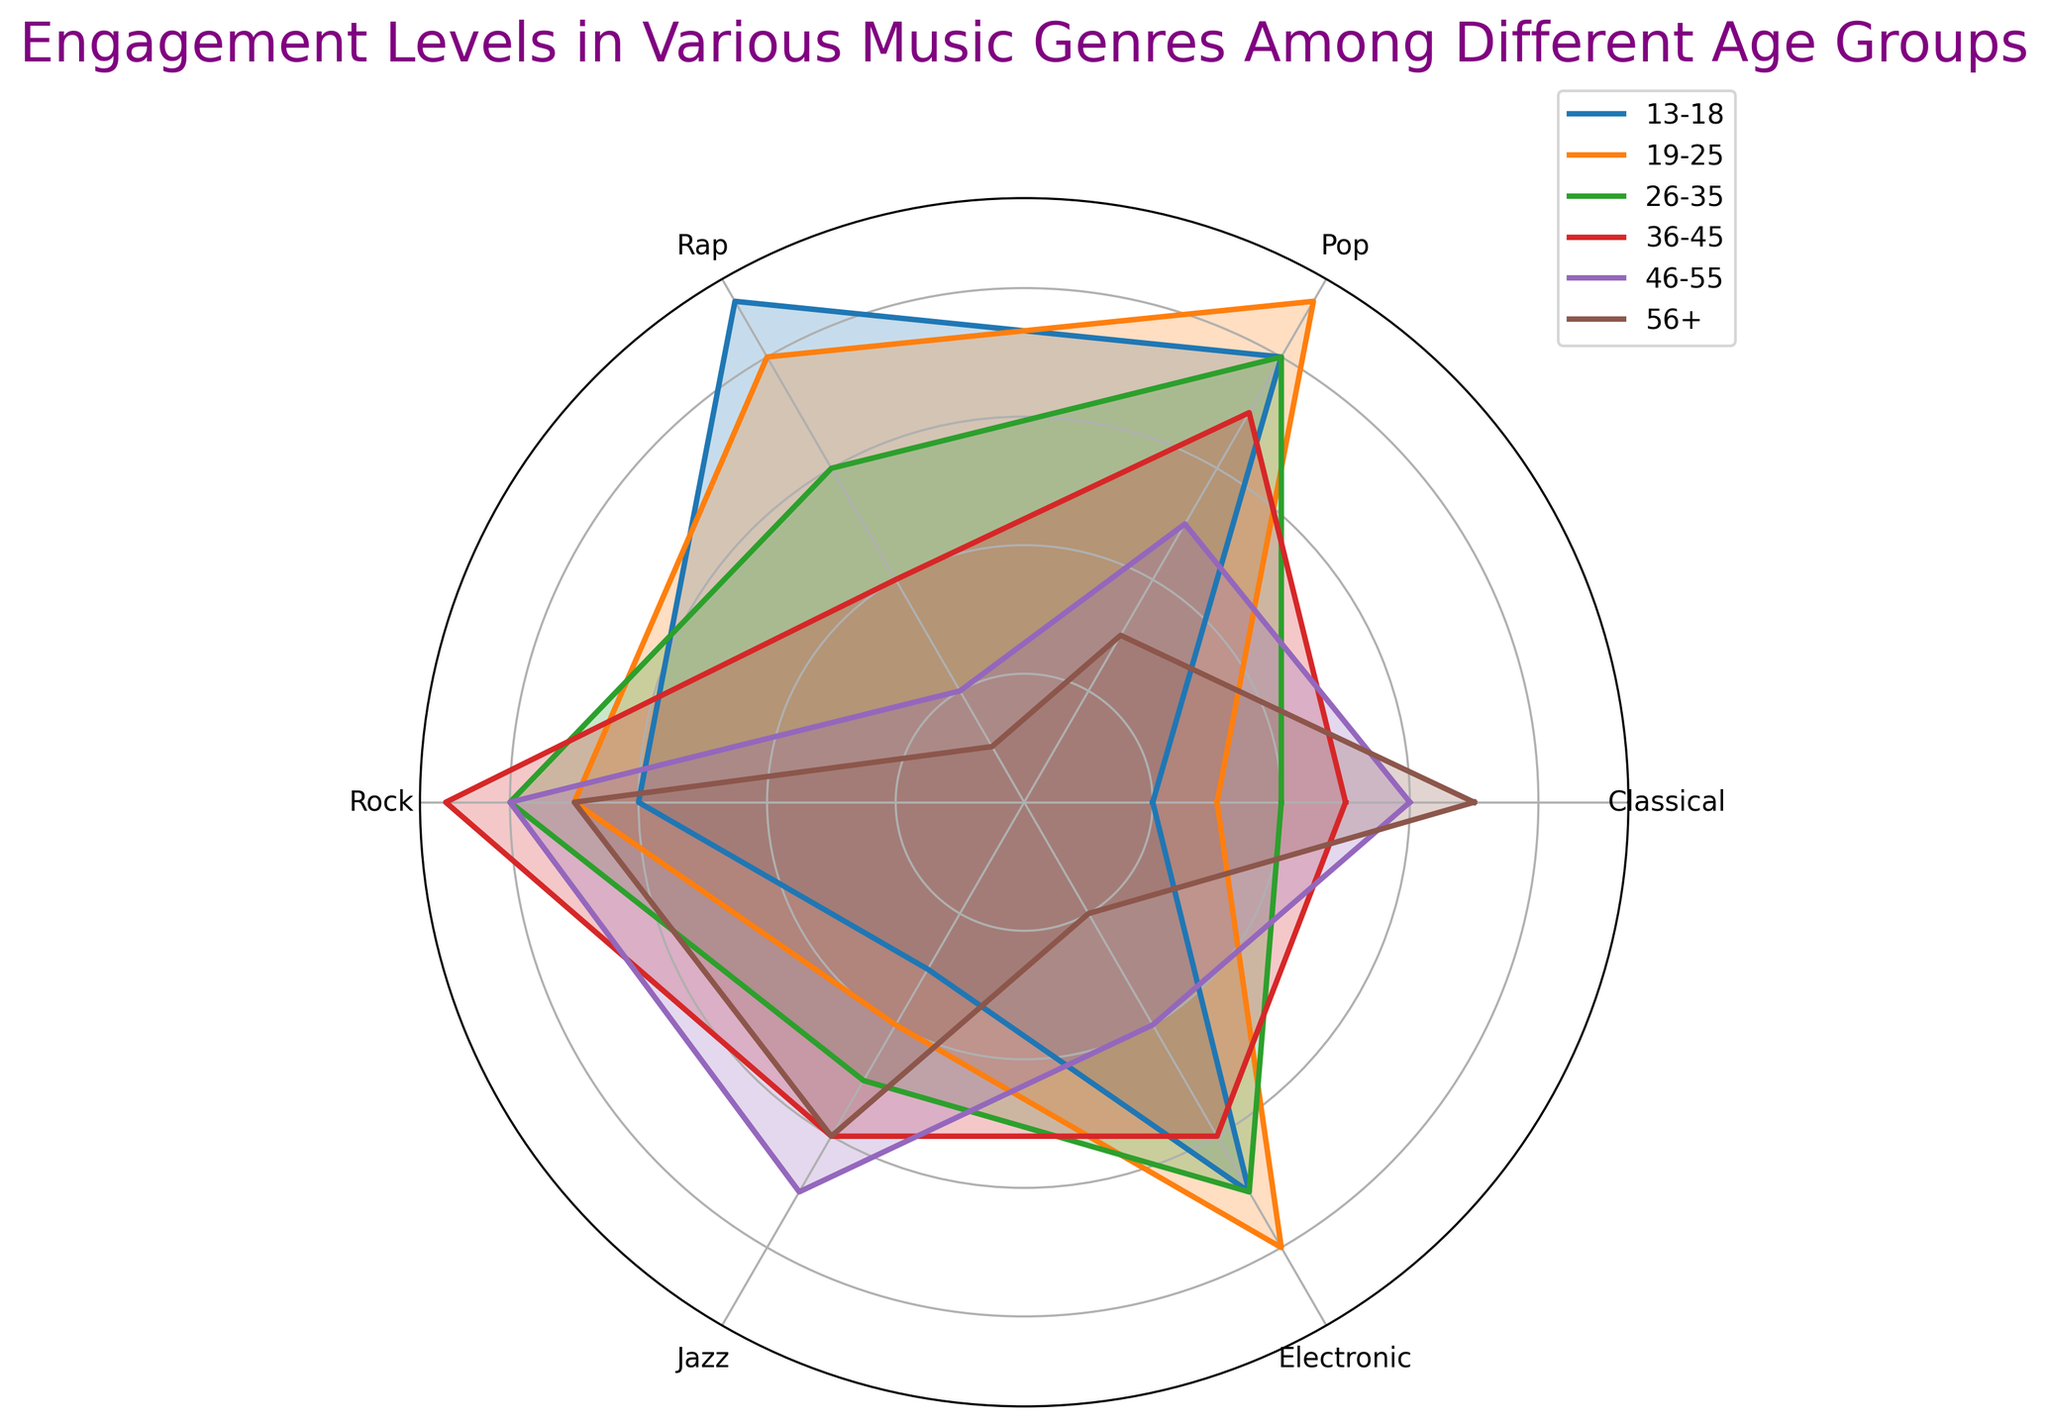Which age group shows the highest engagement in Classical music? By visually inspecting the radar chart, find the line corresponding to Classical music which extends furthest from the center. This occurs at 56+ age group.
Answer: 56+ How does engagement in Jazz compare between age groups 19-25 and 46-55? Compare the lengths of the lines for Jazz at these two age groups. The 46-55 age group shows slightly higher engagement in Jazz (7) compared to the 19-25 age group (4).
Answer: 46-55 > 19-25 What's the average engagement level in Rock music across all age groups? Sum the engagement levels in Rock music across all age groups (6 + 7 + 8 + 9 + 8 + 7 = 45). There are 6 age groups, so the average is 45 / 6 = 7.5.
Answer: 7.5 Which genre has the least variance in engagement levels across all age groups? Look for the genre where the lines are most closely grouped together. Electronic music has a range (2 to 8) indicating higher variance, unlike Jazz which ranges from 3 to 7, a smaller variance.
Answer: Jazz Compare the engagement levels in Rap music between the youngest (13-18) and oldest (56+) age groups. What is the difference? The engagement level in Rap music for age group 13-18 is 9, and for age group 56+ is 1. The difference is 9 - 1 = 8.
Answer: 8 Which age group shows the most balanced engagement across all music genres? Look for the age group with radar lines forming a more regular polygon, indicating balance. The 26-35 age group shows relatively balanced engagement levels in almost all genres.
Answer: 26-35 Which genre is the least preferred by the 46-55 age group? The shortest line for the 46-55 age group indicates the least engagement. For this age group, Rap music has the least engagement level (2).
Answer: Rap Identify the genre where engagement decreases consistently as the age group increases. Observe genre lines from center to outer edges. Rap consistently shows declining engagement from youngest to oldest age group.
Answer: Rap What is the sum of engagement levels in Pop music for the age groups 13-18 and 19-25? Sum the engagement levels in Pop music for age groups 13-18 (8) and 19-25 (9). So, 8 + 9 = 17.
Answer: 17 